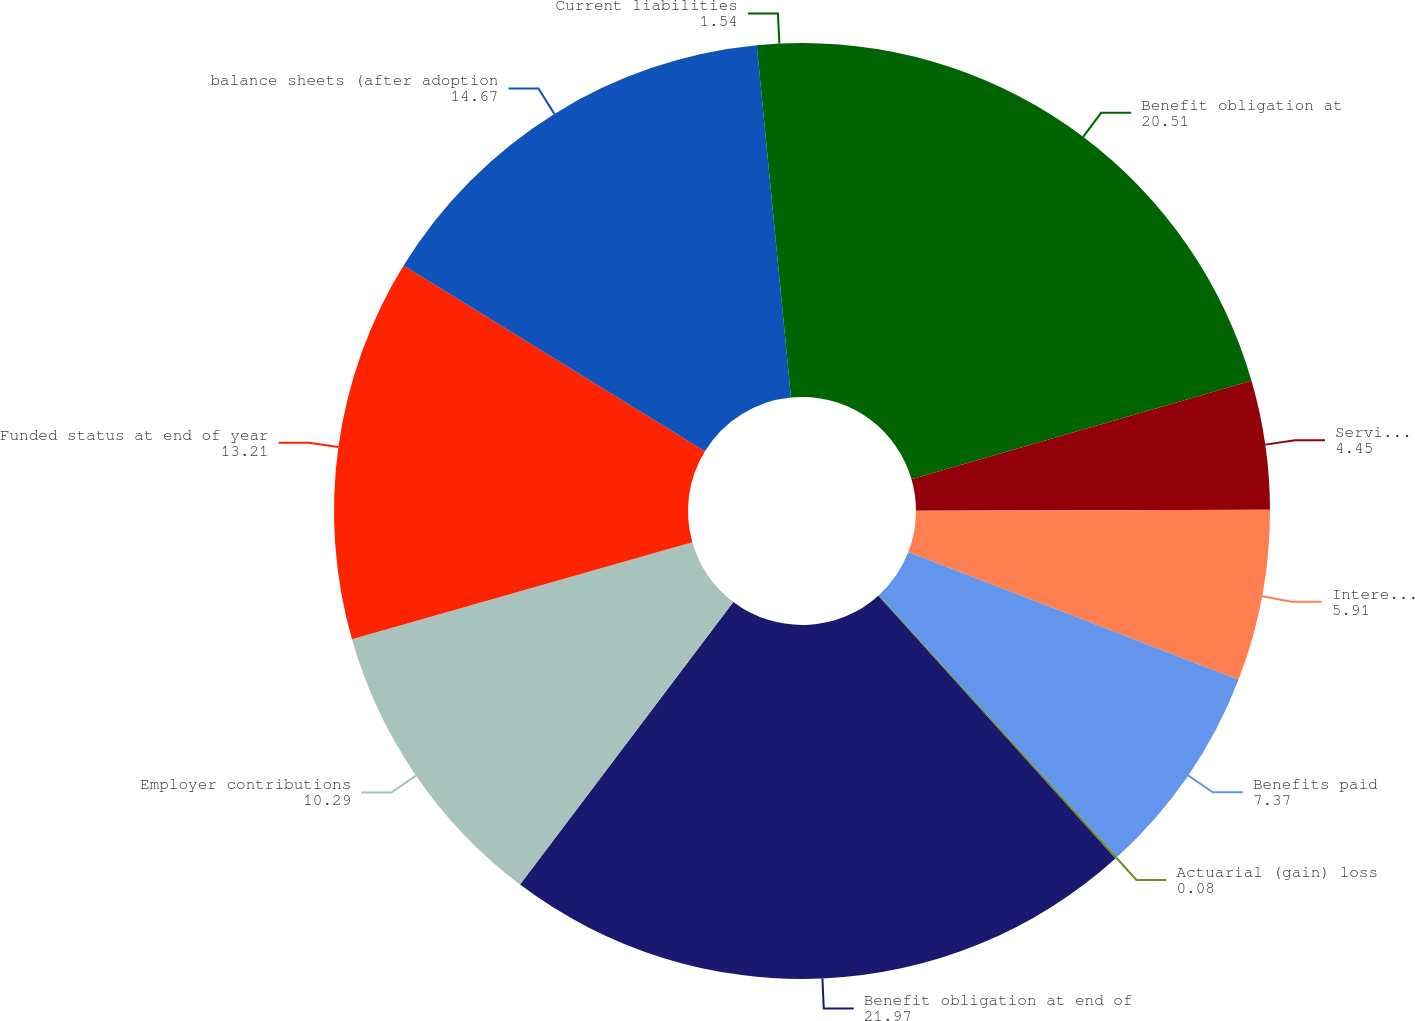<chart> <loc_0><loc_0><loc_500><loc_500><pie_chart><fcel>Benefit obligation at<fcel>Service cost<fcel>Interest cost<fcel>Benefits paid<fcel>Actuarial (gain) loss<fcel>Benefit obligation at end of<fcel>Employer contributions<fcel>Funded status at end of year<fcel>balance sheets (after adoption<fcel>Current liabilities<nl><fcel>20.51%<fcel>4.45%<fcel>5.91%<fcel>7.37%<fcel>0.08%<fcel>21.97%<fcel>10.29%<fcel>13.21%<fcel>14.67%<fcel>1.54%<nl></chart> 